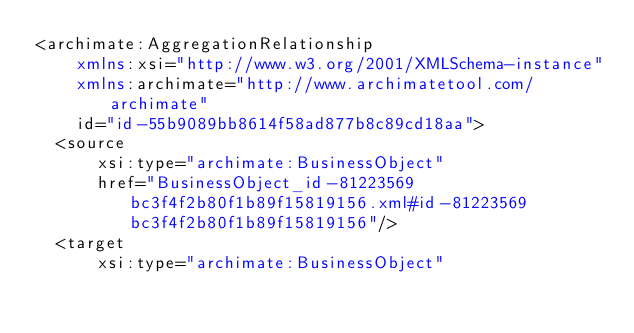<code> <loc_0><loc_0><loc_500><loc_500><_XML_><archimate:AggregationRelationship
    xmlns:xsi="http://www.w3.org/2001/XMLSchema-instance"
    xmlns:archimate="http://www.archimatetool.com/archimate"
    id="id-55b9089bb8614f58ad877b8c89cd18aa">
  <source
      xsi:type="archimate:BusinessObject"
      href="BusinessObject_id-81223569bc3f4f2b80f1b89f15819156.xml#id-81223569bc3f4f2b80f1b89f15819156"/>
  <target
      xsi:type="archimate:BusinessObject"</code> 